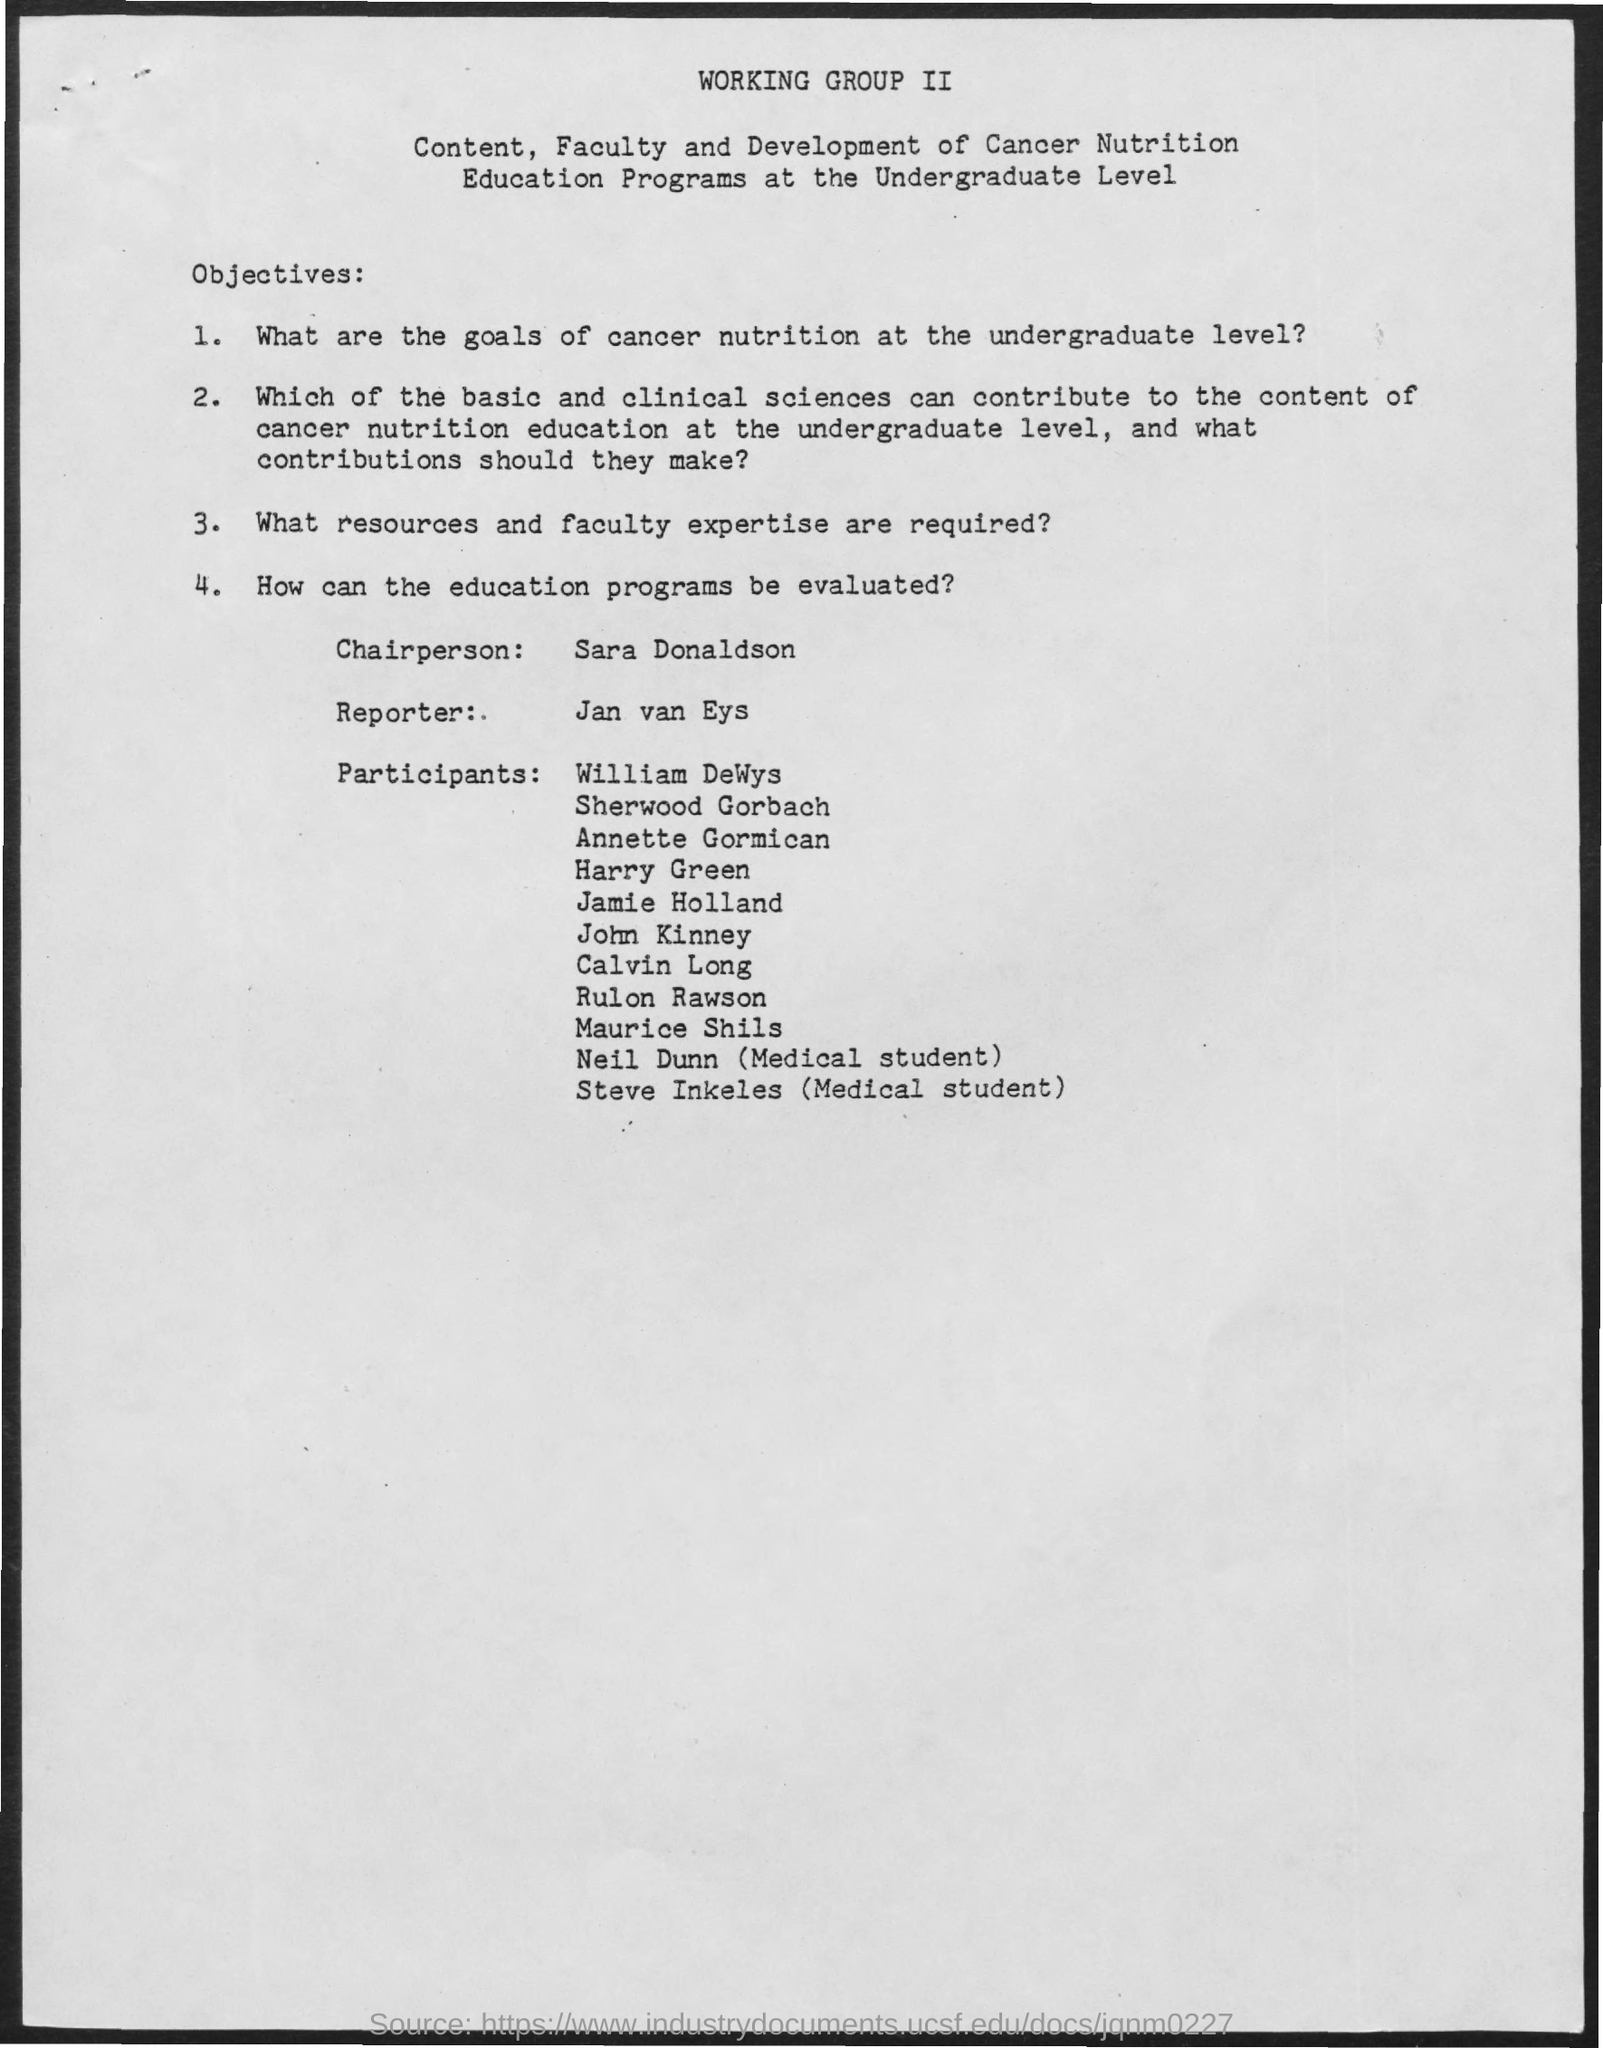Who is the Chairperson?
Keep it short and to the point. Sara donaldson. Who is the Reporter?
Keep it short and to the point. Jan van eys. 